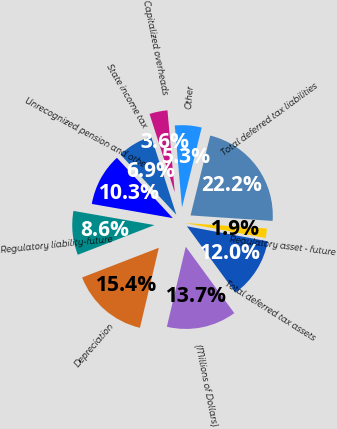Convert chart to OTSL. <chart><loc_0><loc_0><loc_500><loc_500><pie_chart><fcel>(Millions of Dollars)<fcel>Depreciation<fcel>Regulatory liability-future<fcel>Unrecognized pension and other<fcel>State income tax<fcel>Capitalized overheads<fcel>Other<fcel>Total deferred tax liabilities<fcel>Regulatory asset - future<fcel>Total deferred tax assets<nl><fcel>13.73%<fcel>15.43%<fcel>8.64%<fcel>10.34%<fcel>6.94%<fcel>3.55%<fcel>5.25%<fcel>22.22%<fcel>1.85%<fcel>12.04%<nl></chart> 